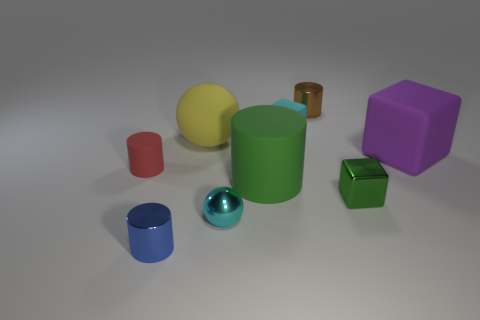How many things are big purple matte cubes or large yellow balls?
Make the answer very short. 2. What is the shape of the metal object that is both in front of the yellow matte ball and to the right of the small cyan cube?
Give a very brief answer. Cube. Is the green thing that is left of the small matte block made of the same material as the brown thing?
Your answer should be compact. No. How many things are either small green shiny things or small rubber things left of the tiny cyan metal thing?
Keep it short and to the point. 2. What is the color of the ball that is made of the same material as the brown object?
Your response must be concise. Cyan. What number of small gray cylinders have the same material as the brown cylinder?
Provide a succinct answer. 0. How many red rubber cylinders are there?
Keep it short and to the point. 1. There is a shiny cylinder in front of the small metal ball; does it have the same color as the small matte object that is to the left of the small cyan cube?
Keep it short and to the point. No. How many yellow spheres are in front of the red cylinder?
Provide a short and direct response. 0. There is a cylinder that is the same color as the small metal cube; what material is it?
Offer a terse response. Rubber. 